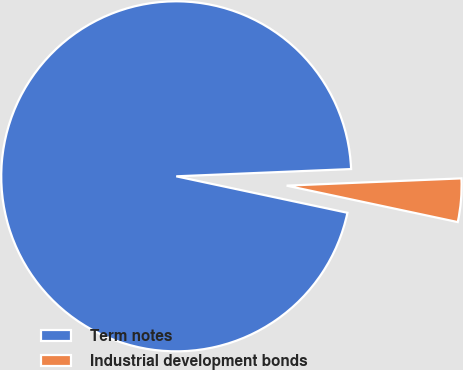Convert chart. <chart><loc_0><loc_0><loc_500><loc_500><pie_chart><fcel>Term notes<fcel>Industrial development bonds<nl><fcel>96.0%<fcel>4.0%<nl></chart> 